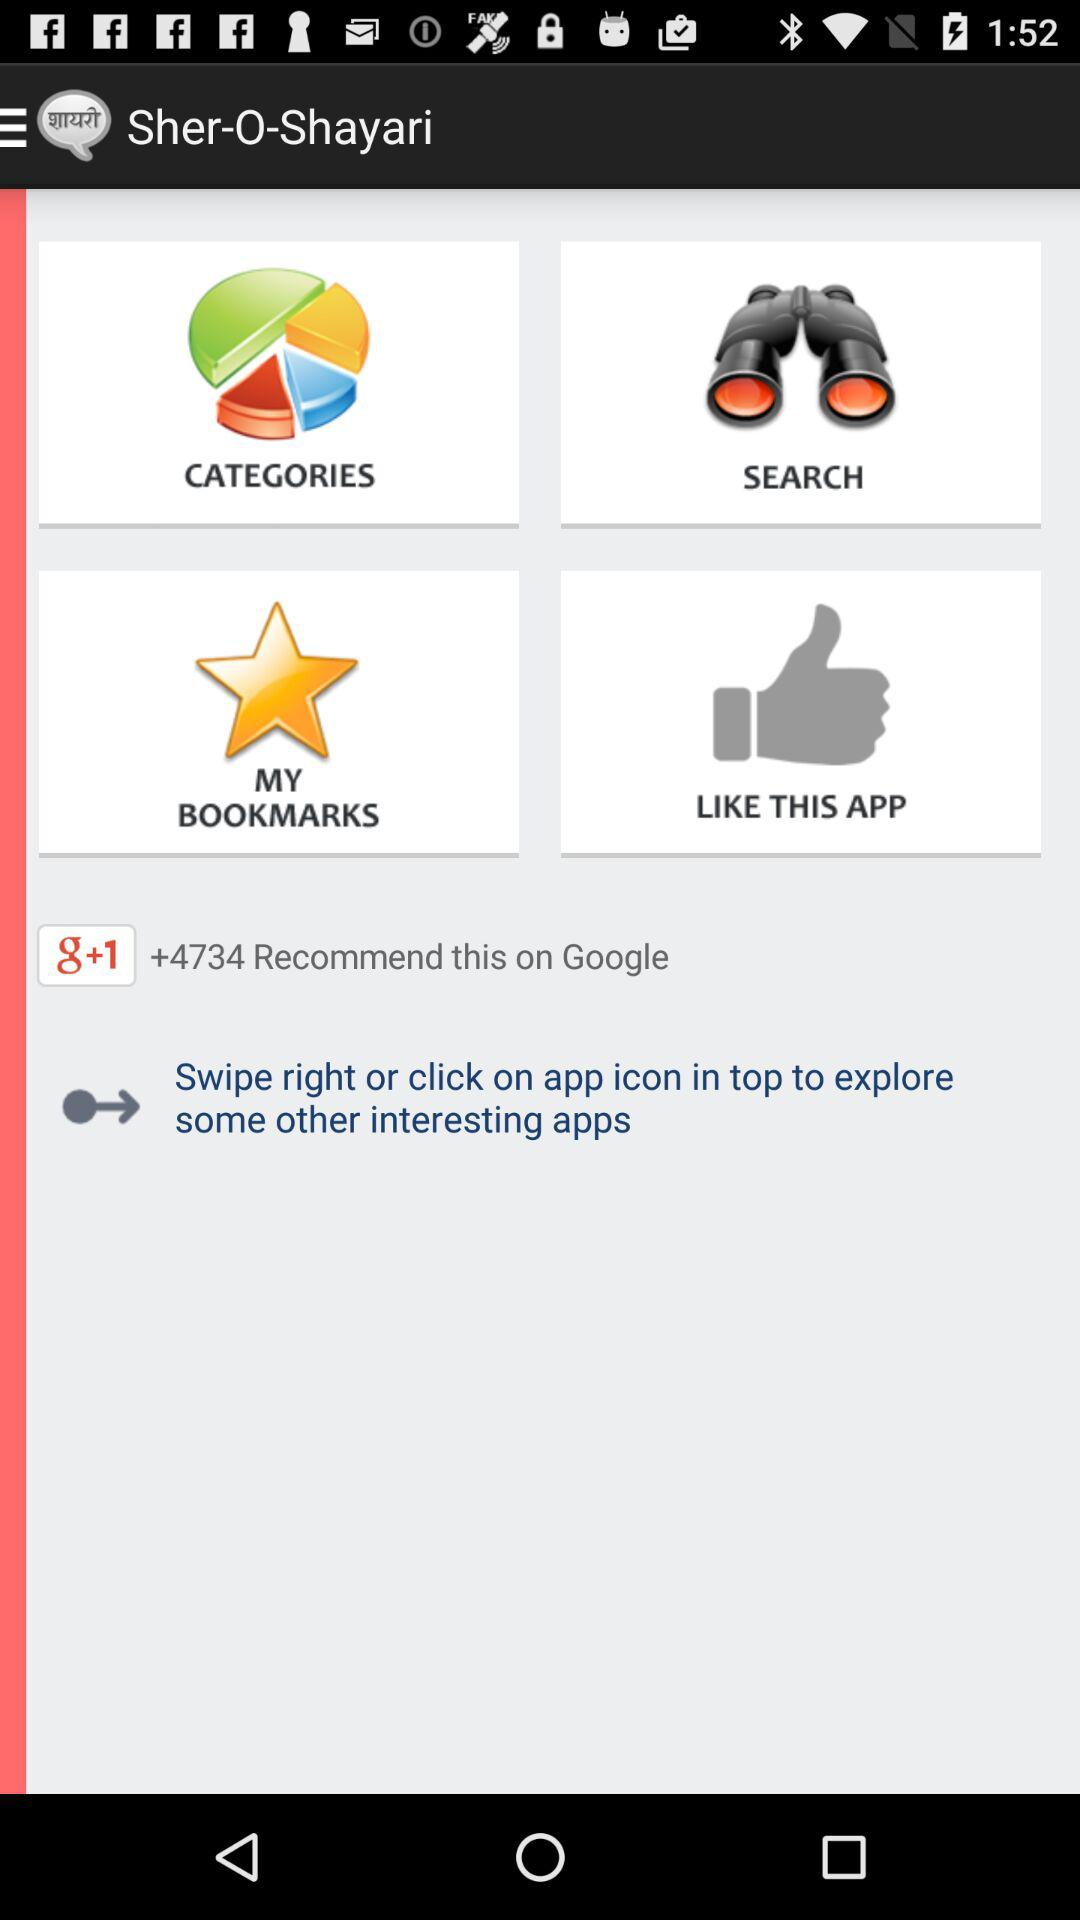How many bookmarks are there?
When the provided information is insufficient, respond with <no answer>. <no answer> 